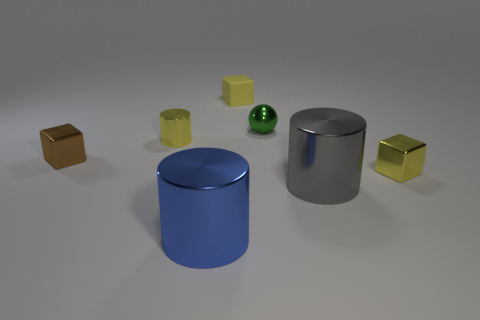What material is the green ball that is the same size as the brown object?
Keep it short and to the point. Metal. There is a yellow block that is in front of the tiny metallic cube that is on the left side of the big gray metallic cylinder that is in front of the small yellow shiny cylinder; what size is it?
Offer a very short reply. Small. What number of other things are there of the same material as the tiny green thing
Make the answer very short. 5. There is a yellow block in front of the small green object; what is its size?
Keep it short and to the point. Small. How many objects are both in front of the tiny matte cube and to the left of the green thing?
Make the answer very short. 3. What is the material of the tiny yellow block on the left side of the metal object that is behind the small metallic cylinder?
Your answer should be very brief. Rubber. Are any metallic balls visible?
Give a very brief answer. Yes. What is the shape of the green object that is the same material as the tiny yellow cylinder?
Keep it short and to the point. Sphere. What material is the yellow cube left of the gray shiny object?
Keep it short and to the point. Rubber. Is the color of the metal cylinder behind the yellow metal block the same as the tiny rubber object?
Provide a succinct answer. Yes. 